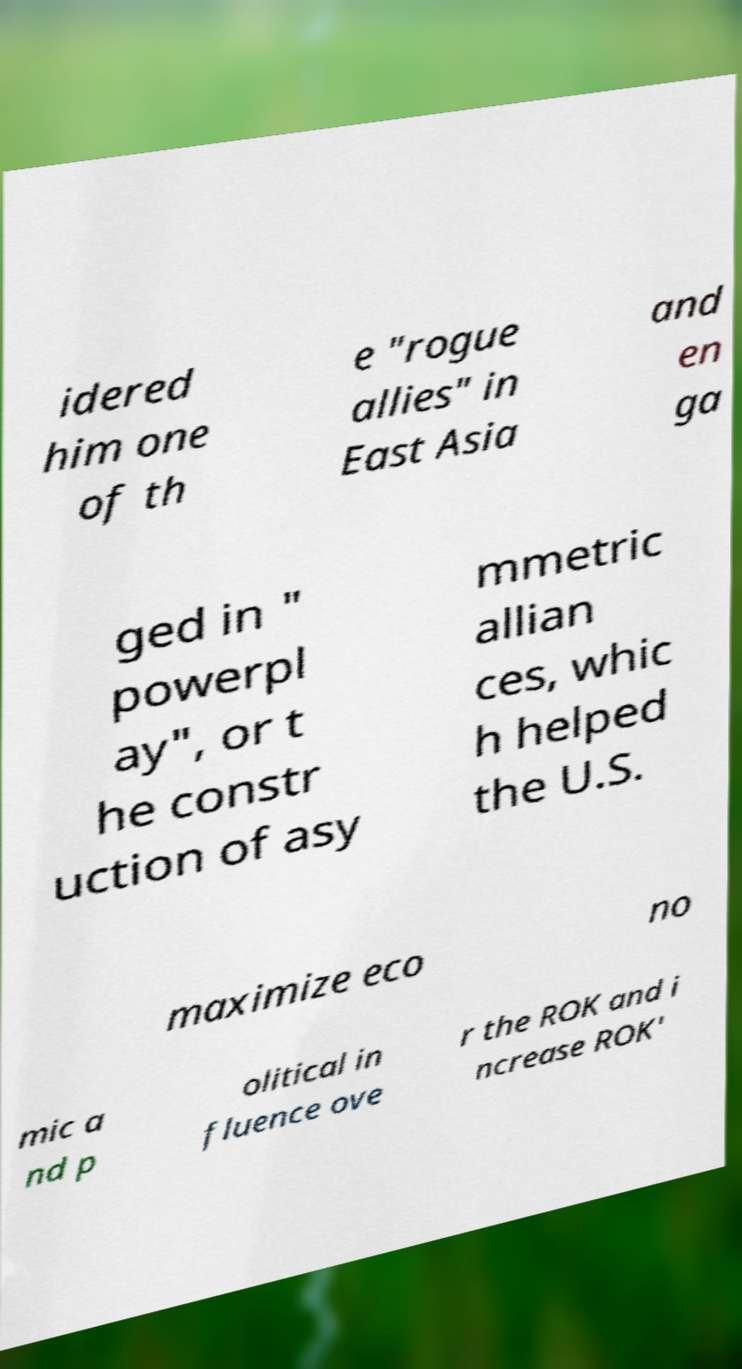I need the written content from this picture converted into text. Can you do that? idered him one of th e "rogue allies" in East Asia and en ga ged in " powerpl ay", or t he constr uction of asy mmetric allian ces, whic h helped the U.S. maximize eco no mic a nd p olitical in fluence ove r the ROK and i ncrease ROK' 